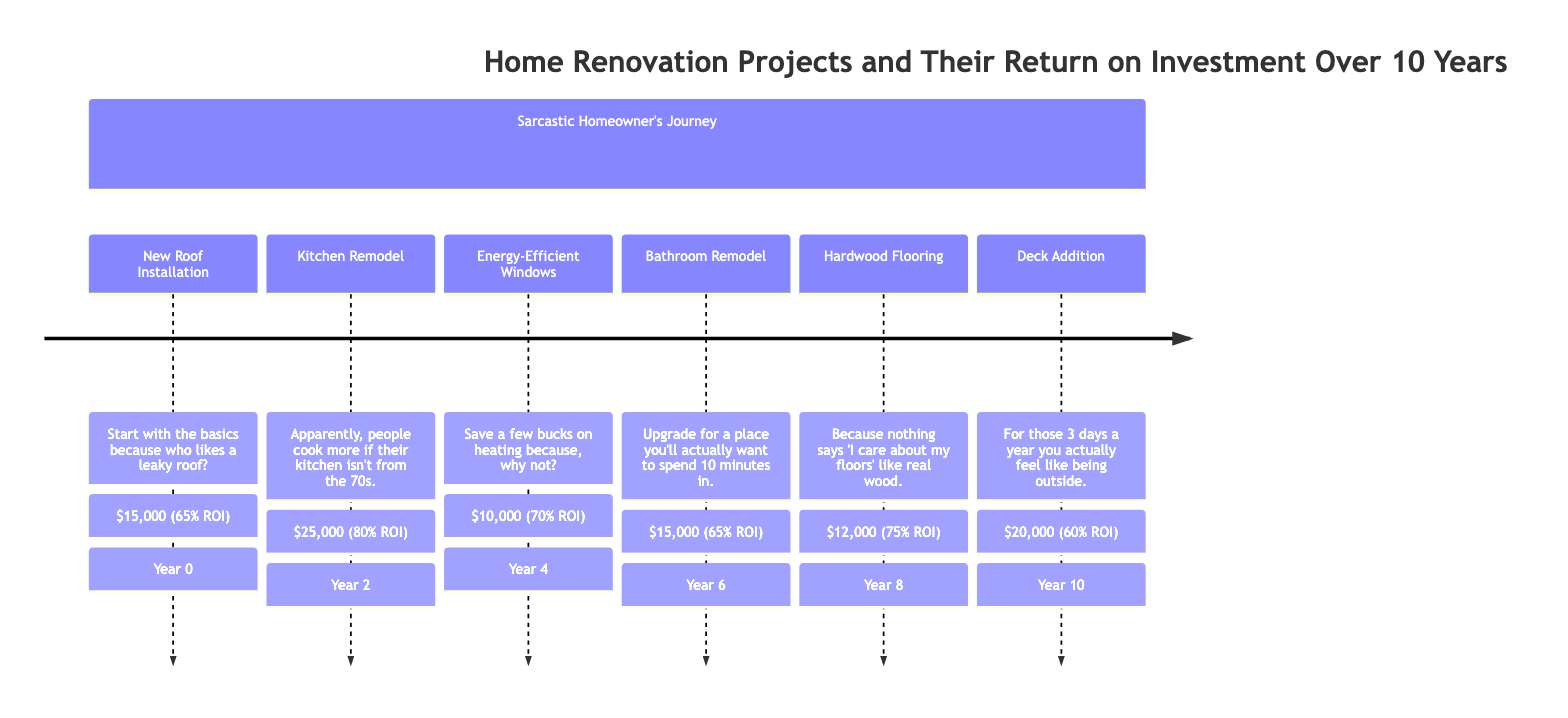What is the cost of the Kitchen Remodel? The diagram states that the Kitchen Remodel, which is planned for Year 2, has a listed cost of $25,000.
Answer: $25,000 What is the expected ROI for the Energy-Efficient Windows? In Year 4, the Energy-Efficient Windows project has an expected return on investment of 70%, as indicated in the diagram.
Answer: 70% Which project has the highest expected ROI? Comparing all the projects listed, the Kitchen Remodel has the highest expected return on investment at 80%, which is noted in Year 2 of the timeline.
Answer: 80% How much was spent on the Bathroom Remodel? The diagram specifies that the cost of the Bathroom Remodel in Year 6 is $15,000, clearly stated alongside the project details.
Answer: $15,000 What year did the Deck Addition take place? The timeline indicates that the Deck Addition project is scheduled for Year 10, as specified at that point in the diagram.
Answer: Year 10 Which project was completed in Year 8? According to the timeline, Year 8 features the Hardwood Flooring project, as described in that section of the diagram.
Answer: Hardwood Flooring What is the cumulative cost of the projects completed by Year 4? By adding the costs of the New Roof Installation ($15,000), Kitchen Remodel ($25,000), and Energy-Efficient Windows ($10,000) up to Year 4, the total comes to $50,000.
Answer: $50,000 What is the expected ROI for the Deck Addition? In Year 10, the Deck Addition is listed with an expected return on investment of 60%, found at that point in the diagram.
Answer: 60% How many projects are listed in total? There are a total of 6 renovation projects listed in the timeline, as seen from Year 0 to Year 10.
Answer: 6 